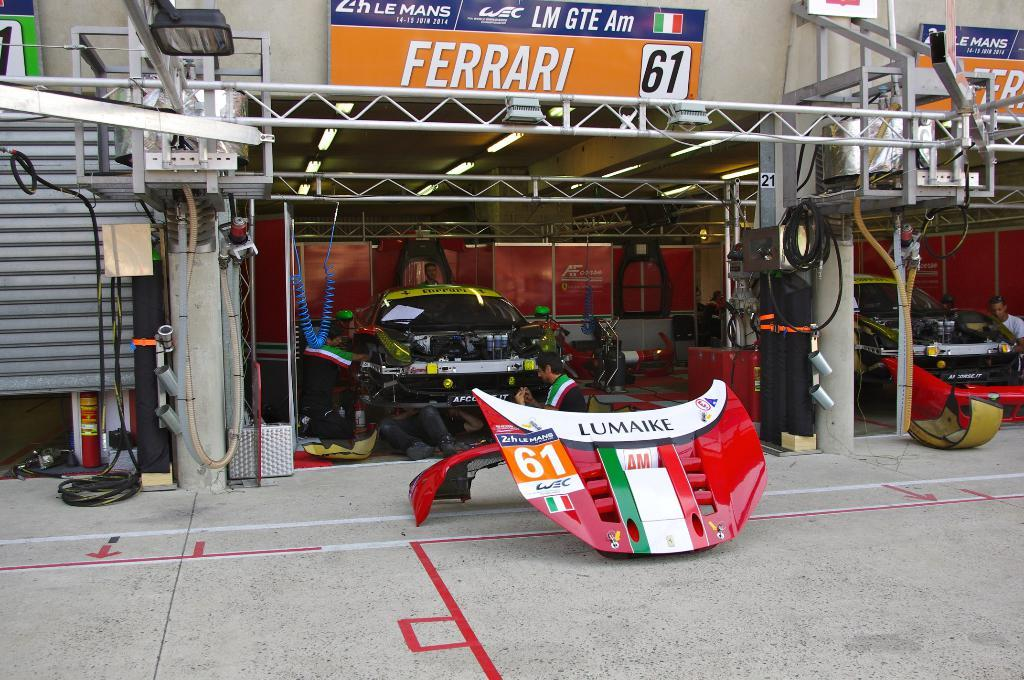What type of structure is visible in the image? There is a garage in the image. What can be found inside the garage? There are cars inside the garage. What are the people in the image doing? People are working in the garage. Are there any signs or notices in the image? Yes, there are boards with text in the image. What type of music can be heard playing in the garage? There is no information about music in the image, so it cannot be determined if any music is playing. 